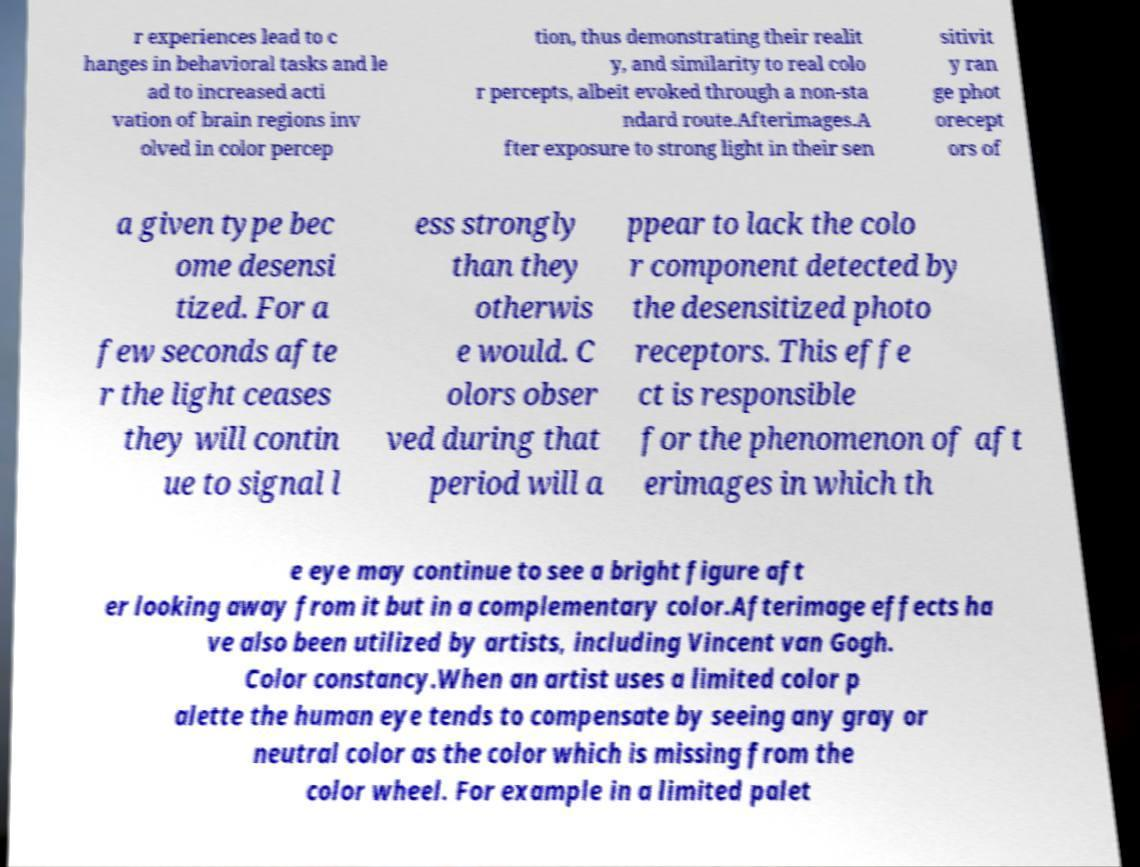Please identify and transcribe the text found in this image. r experiences lead to c hanges in behavioral tasks and le ad to increased acti vation of brain regions inv olved in color percep tion, thus demonstrating their realit y, and similarity to real colo r percepts, albeit evoked through a non-sta ndard route.Afterimages.A fter exposure to strong light in their sen sitivit y ran ge phot orecept ors of a given type bec ome desensi tized. For a few seconds afte r the light ceases they will contin ue to signal l ess strongly than they otherwis e would. C olors obser ved during that period will a ppear to lack the colo r component detected by the desensitized photo receptors. This effe ct is responsible for the phenomenon of aft erimages in which th e eye may continue to see a bright figure aft er looking away from it but in a complementary color.Afterimage effects ha ve also been utilized by artists, including Vincent van Gogh. Color constancy.When an artist uses a limited color p alette the human eye tends to compensate by seeing any gray or neutral color as the color which is missing from the color wheel. For example in a limited palet 